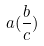<formula> <loc_0><loc_0><loc_500><loc_500>a ( \frac { b } { c } )</formula> 